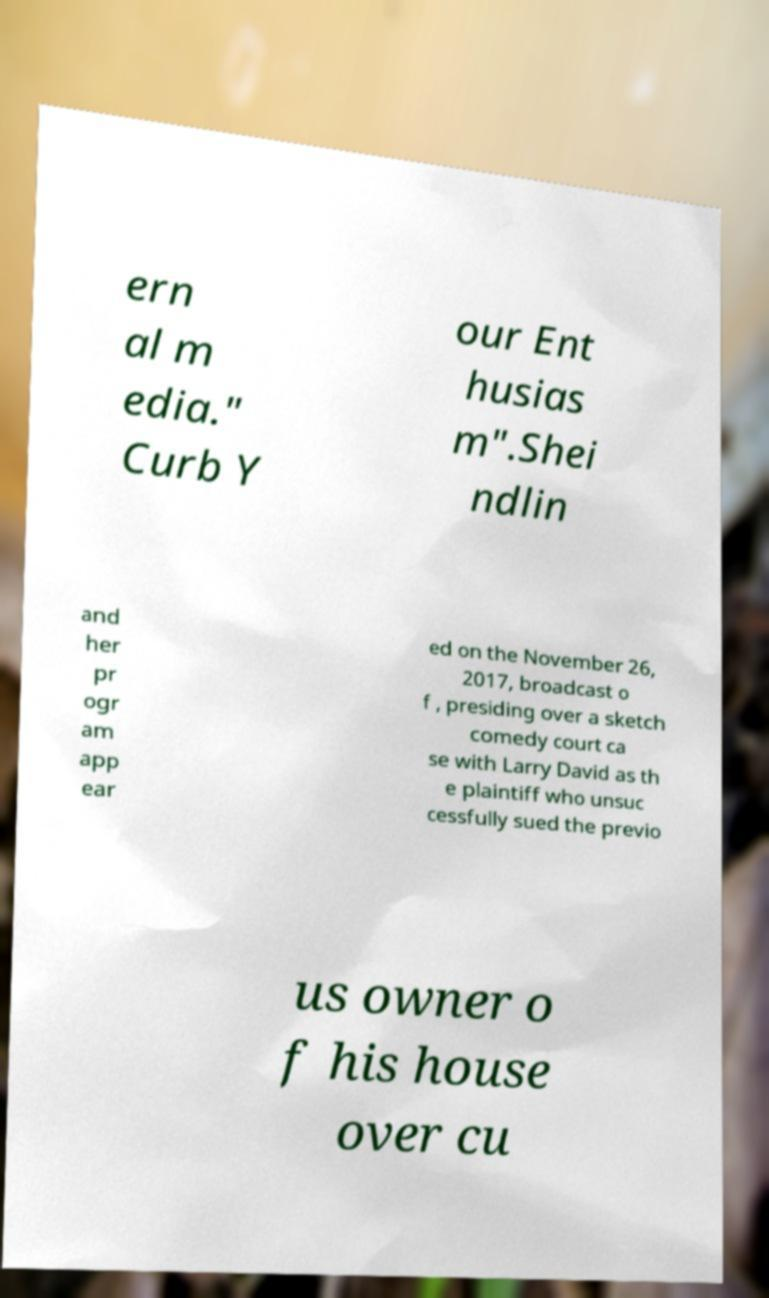Please read and relay the text visible in this image. What does it say? ern al m edia." Curb Y our Ent husias m".Shei ndlin and her pr ogr am app ear ed on the November 26, 2017, broadcast o f , presiding over a sketch comedy court ca se with Larry David as th e plaintiff who unsuc cessfully sued the previo us owner o f his house over cu 